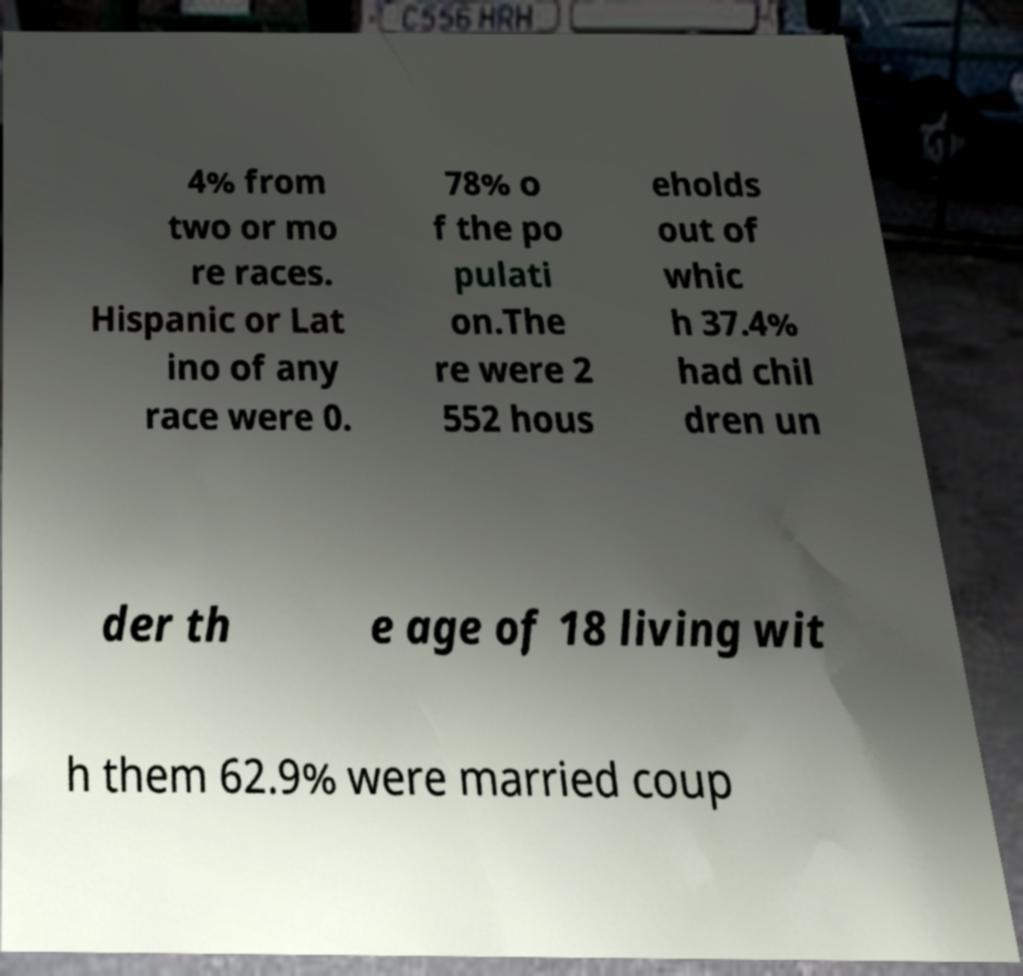Can you accurately transcribe the text from the provided image for me? 4% from two or mo re races. Hispanic or Lat ino of any race were 0. 78% o f the po pulati on.The re were 2 552 hous eholds out of whic h 37.4% had chil dren un der th e age of 18 living wit h them 62.9% were married coup 